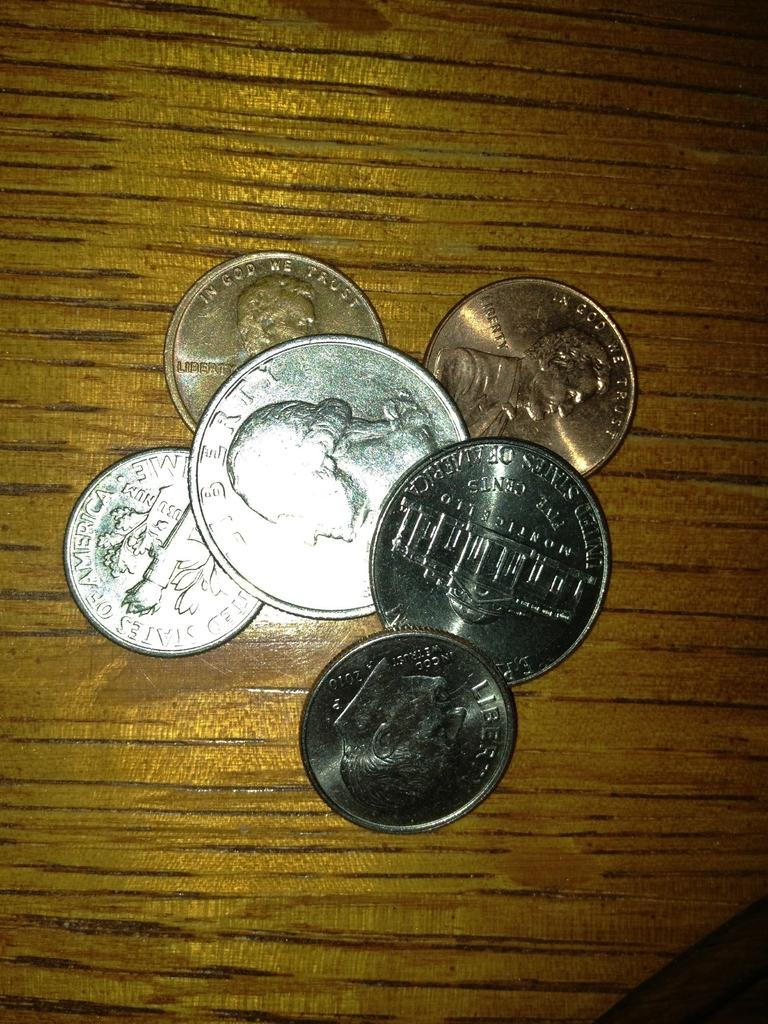<image>
Summarize the visual content of the image. A bunch of coins on a table the quarter says liberty. 